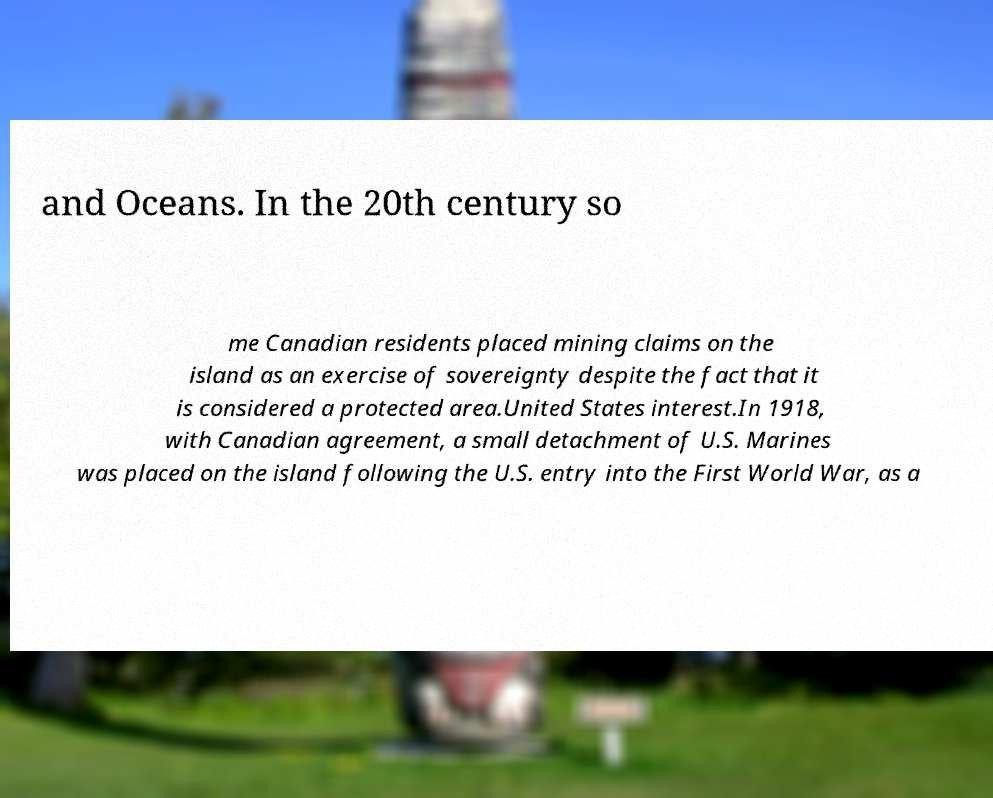Please read and relay the text visible in this image. What does it say? and Oceans. In the 20th century so me Canadian residents placed mining claims on the island as an exercise of sovereignty despite the fact that it is considered a protected area.United States interest.In 1918, with Canadian agreement, a small detachment of U.S. Marines was placed on the island following the U.S. entry into the First World War, as a 